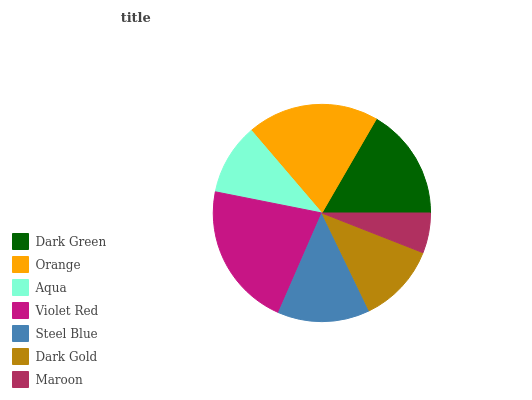Is Maroon the minimum?
Answer yes or no. Yes. Is Violet Red the maximum?
Answer yes or no. Yes. Is Orange the minimum?
Answer yes or no. No. Is Orange the maximum?
Answer yes or no. No. Is Orange greater than Dark Green?
Answer yes or no. Yes. Is Dark Green less than Orange?
Answer yes or no. Yes. Is Dark Green greater than Orange?
Answer yes or no. No. Is Orange less than Dark Green?
Answer yes or no. No. Is Steel Blue the high median?
Answer yes or no. Yes. Is Steel Blue the low median?
Answer yes or no. Yes. Is Aqua the high median?
Answer yes or no. No. Is Violet Red the low median?
Answer yes or no. No. 